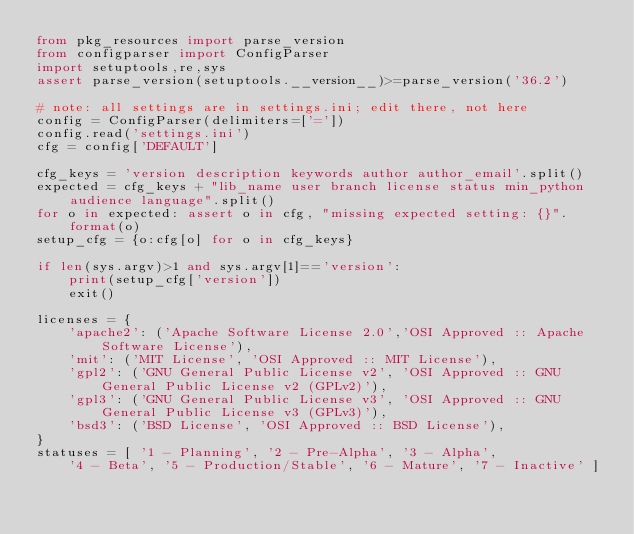Convert code to text. <code><loc_0><loc_0><loc_500><loc_500><_Python_>from pkg_resources import parse_version
from configparser import ConfigParser
import setuptools,re,sys
assert parse_version(setuptools.__version__)>=parse_version('36.2')

# note: all settings are in settings.ini; edit there, not here
config = ConfigParser(delimiters=['='])
config.read('settings.ini')
cfg = config['DEFAULT']

cfg_keys = 'version description keywords author author_email'.split()
expected = cfg_keys + "lib_name user branch license status min_python audience language".split()
for o in expected: assert o in cfg, "missing expected setting: {}".format(o)
setup_cfg = {o:cfg[o] for o in cfg_keys}

if len(sys.argv)>1 and sys.argv[1]=='version':
    print(setup_cfg['version'])
    exit()

licenses = {
    'apache2': ('Apache Software License 2.0','OSI Approved :: Apache Software License'),
    'mit': ('MIT License', 'OSI Approved :: MIT License'),
    'gpl2': ('GNU General Public License v2', 'OSI Approved :: GNU General Public License v2 (GPLv2)'),
    'gpl3': ('GNU General Public License v3', 'OSI Approved :: GNU General Public License v3 (GPLv3)'),
    'bsd3': ('BSD License', 'OSI Approved :: BSD License'),
}
statuses = [ '1 - Planning', '2 - Pre-Alpha', '3 - Alpha',
    '4 - Beta', '5 - Production/Stable', '6 - Mature', '7 - Inactive' ]</code> 